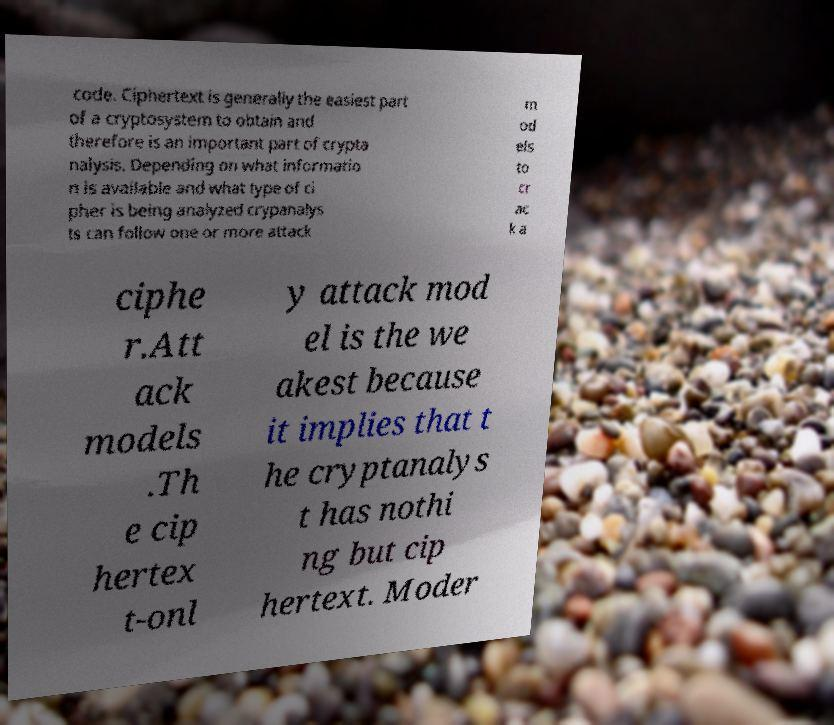Could you extract and type out the text from this image? code. Ciphertext is generally the easiest part of a cryptosystem to obtain and therefore is an important part of crypta nalysis. Depending on what informatio n is available and what type of ci pher is being analyzed crypanalys ts can follow one or more attack m od els to cr ac k a ciphe r.Att ack models .Th e cip hertex t-onl y attack mod el is the we akest because it implies that t he cryptanalys t has nothi ng but cip hertext. Moder 